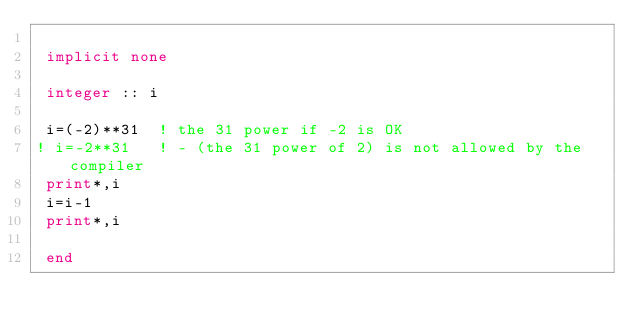Convert code to text. <code><loc_0><loc_0><loc_500><loc_500><_FORTRAN_>
 implicit none

 integer :: i

 i=(-2)**31  ! the 31 power if -2 is OK
! i=-2**31   ! - (the 31 power of 2) is not allowed by the compiler
 print*,i
 i=i-1
 print*,i

 end
</code> 